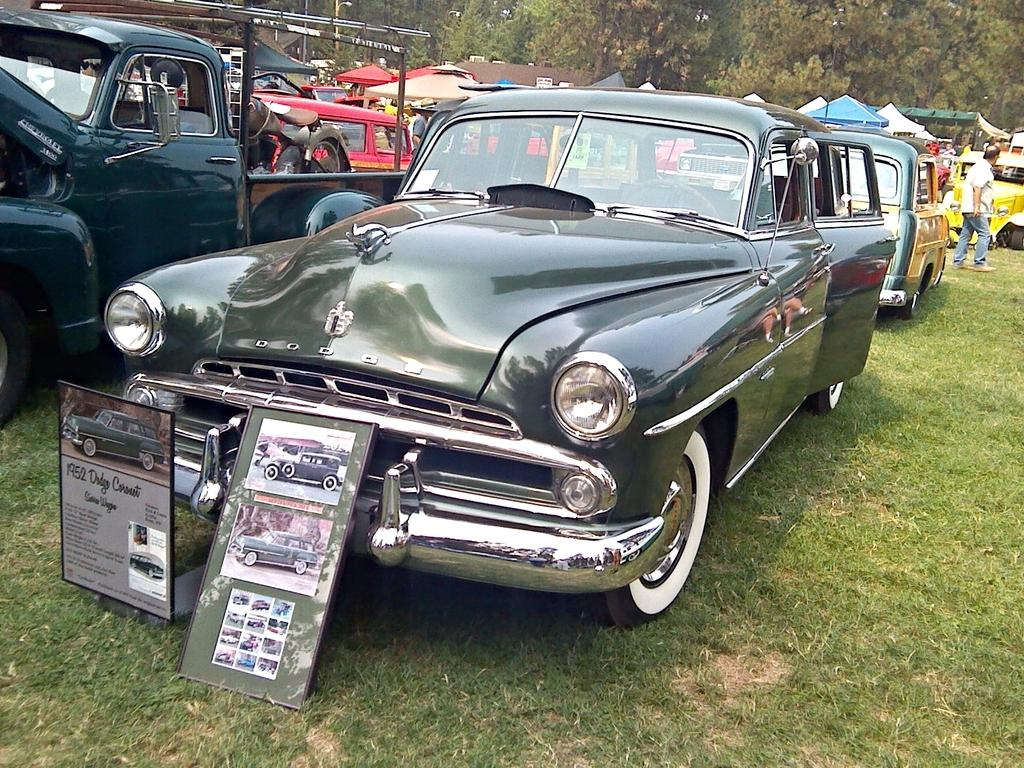What types of objects are present in the image? There are vehicles in the image. What can be seen on the ground in the image? There is grass visible in the image. What is visible in the distance in the image? There are trees in the background of the image. What flavor of mask is being worn by the person in the image? There is no person or mask present in the image; it features vehicles and a grassy area with trees in the background. 